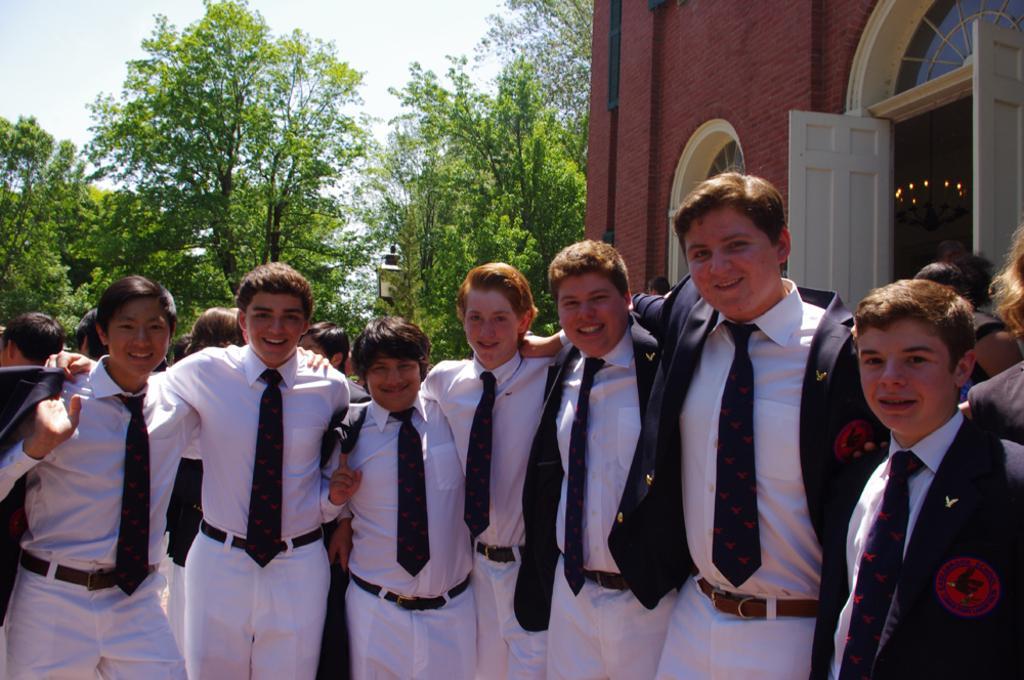How would you summarize this image in a sentence or two? In this I can see few people are standing and I can see a building and few trees in the back and I can see a cloudy sky. 